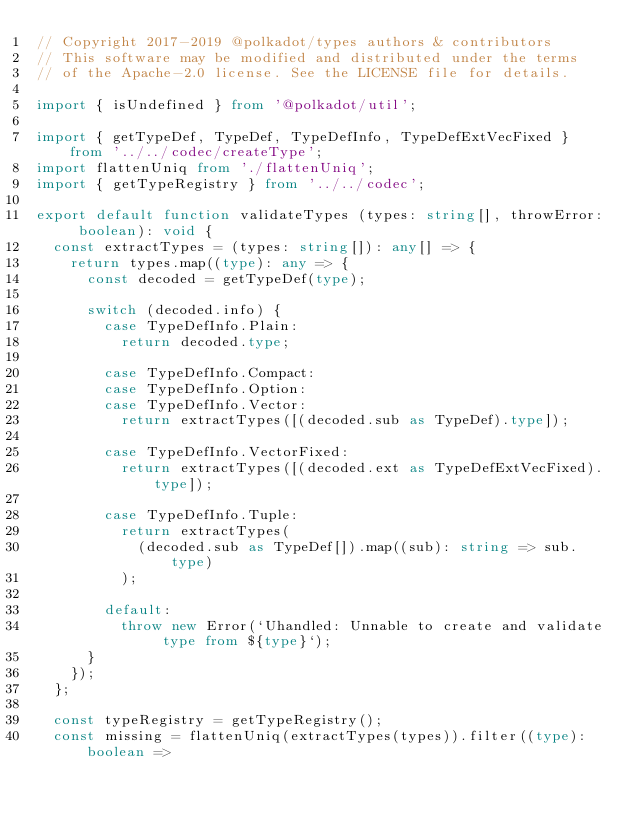<code> <loc_0><loc_0><loc_500><loc_500><_TypeScript_>// Copyright 2017-2019 @polkadot/types authors & contributors
// This software may be modified and distributed under the terms
// of the Apache-2.0 license. See the LICENSE file for details.

import { isUndefined } from '@polkadot/util';

import { getTypeDef, TypeDef, TypeDefInfo, TypeDefExtVecFixed } from '../../codec/createType';
import flattenUniq from './flattenUniq';
import { getTypeRegistry } from '../../codec';

export default function validateTypes (types: string[], throwError: boolean): void {
  const extractTypes = (types: string[]): any[] => {
    return types.map((type): any => {
      const decoded = getTypeDef(type);

      switch (decoded.info) {
        case TypeDefInfo.Plain:
          return decoded.type;

        case TypeDefInfo.Compact:
        case TypeDefInfo.Option:
        case TypeDefInfo.Vector:
          return extractTypes([(decoded.sub as TypeDef).type]);

        case TypeDefInfo.VectorFixed:
          return extractTypes([(decoded.ext as TypeDefExtVecFixed).type]);

        case TypeDefInfo.Tuple:
          return extractTypes(
            (decoded.sub as TypeDef[]).map((sub): string => sub.type)
          );

        default:
          throw new Error(`Uhandled: Unnable to create and validate type from ${type}`);
      }
    });
  };

  const typeRegistry = getTypeRegistry();
  const missing = flattenUniq(extractTypes(types)).filter((type): boolean =></code> 